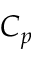<formula> <loc_0><loc_0><loc_500><loc_500>C _ { p }</formula> 